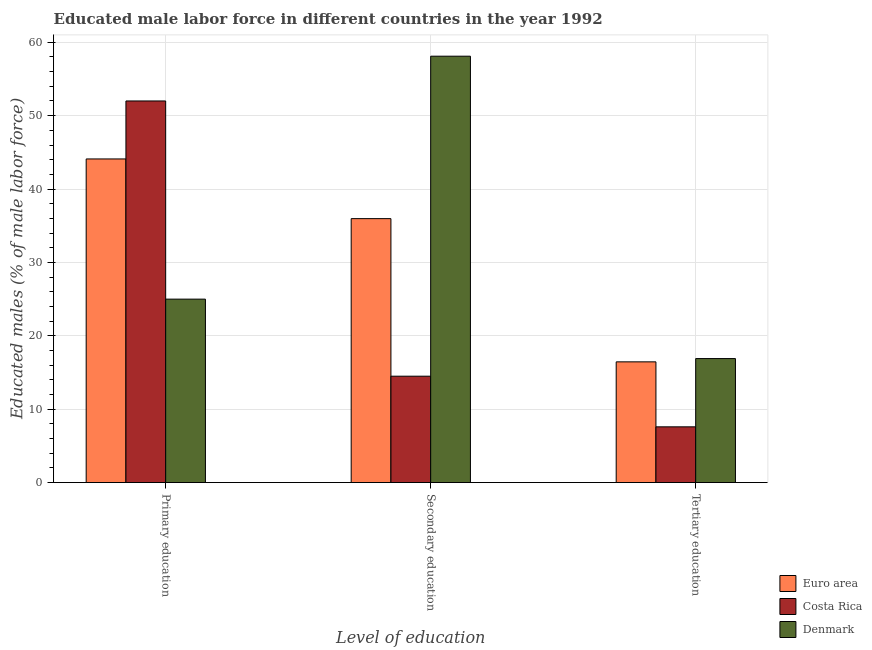Are the number of bars on each tick of the X-axis equal?
Keep it short and to the point. Yes. How many bars are there on the 1st tick from the right?
Give a very brief answer. 3. What is the percentage of male labor force who received secondary education in Euro area?
Offer a terse response. 35.97. Across all countries, what is the maximum percentage of male labor force who received tertiary education?
Give a very brief answer. 16.9. Across all countries, what is the minimum percentage of male labor force who received secondary education?
Offer a terse response. 14.5. In which country was the percentage of male labor force who received primary education maximum?
Provide a succinct answer. Costa Rica. What is the total percentage of male labor force who received tertiary education in the graph?
Ensure brevity in your answer.  40.95. What is the difference between the percentage of male labor force who received secondary education in Euro area and that in Denmark?
Make the answer very short. -22.13. What is the difference between the percentage of male labor force who received primary education in Euro area and the percentage of male labor force who received tertiary education in Costa Rica?
Offer a terse response. 36.5. What is the average percentage of male labor force who received primary education per country?
Keep it short and to the point. 40.37. What is the difference between the percentage of male labor force who received primary education and percentage of male labor force who received secondary education in Denmark?
Make the answer very short. -33.1. What is the ratio of the percentage of male labor force who received tertiary education in Denmark to that in Euro area?
Offer a very short reply. 1.03. Is the percentage of male labor force who received secondary education in Denmark less than that in Costa Rica?
Your answer should be very brief. No. What is the difference between the highest and the second highest percentage of male labor force who received secondary education?
Make the answer very short. 22.13. What is the difference between the highest and the lowest percentage of male labor force who received tertiary education?
Provide a succinct answer. 9.3. Is the sum of the percentage of male labor force who received primary education in Costa Rica and Euro area greater than the maximum percentage of male labor force who received secondary education across all countries?
Your answer should be compact. Yes. What does the 1st bar from the left in Tertiary education represents?
Provide a succinct answer. Euro area. What does the 3rd bar from the right in Secondary education represents?
Your answer should be very brief. Euro area. How many bars are there?
Provide a succinct answer. 9. How many countries are there in the graph?
Offer a very short reply. 3. Are the values on the major ticks of Y-axis written in scientific E-notation?
Keep it short and to the point. No. Does the graph contain any zero values?
Your answer should be compact. No. Does the graph contain grids?
Give a very brief answer. Yes. What is the title of the graph?
Provide a short and direct response. Educated male labor force in different countries in the year 1992. Does "High income: OECD" appear as one of the legend labels in the graph?
Your answer should be very brief. No. What is the label or title of the X-axis?
Your answer should be very brief. Level of education. What is the label or title of the Y-axis?
Your response must be concise. Educated males (% of male labor force). What is the Educated males (% of male labor force) of Euro area in Primary education?
Your response must be concise. 44.1. What is the Educated males (% of male labor force) of Euro area in Secondary education?
Ensure brevity in your answer.  35.97. What is the Educated males (% of male labor force) of Costa Rica in Secondary education?
Offer a very short reply. 14.5. What is the Educated males (% of male labor force) of Denmark in Secondary education?
Provide a succinct answer. 58.1. What is the Educated males (% of male labor force) of Euro area in Tertiary education?
Your answer should be very brief. 16.45. What is the Educated males (% of male labor force) in Costa Rica in Tertiary education?
Offer a very short reply. 7.6. What is the Educated males (% of male labor force) in Denmark in Tertiary education?
Your answer should be very brief. 16.9. Across all Level of education, what is the maximum Educated males (% of male labor force) in Euro area?
Make the answer very short. 44.1. Across all Level of education, what is the maximum Educated males (% of male labor force) of Denmark?
Your response must be concise. 58.1. Across all Level of education, what is the minimum Educated males (% of male labor force) in Euro area?
Give a very brief answer. 16.45. Across all Level of education, what is the minimum Educated males (% of male labor force) of Costa Rica?
Ensure brevity in your answer.  7.6. Across all Level of education, what is the minimum Educated males (% of male labor force) in Denmark?
Give a very brief answer. 16.9. What is the total Educated males (% of male labor force) in Euro area in the graph?
Ensure brevity in your answer.  96.52. What is the total Educated males (% of male labor force) in Costa Rica in the graph?
Ensure brevity in your answer.  74.1. What is the total Educated males (% of male labor force) in Denmark in the graph?
Provide a succinct answer. 100. What is the difference between the Educated males (% of male labor force) in Euro area in Primary education and that in Secondary education?
Provide a short and direct response. 8.13. What is the difference between the Educated males (% of male labor force) of Costa Rica in Primary education and that in Secondary education?
Your answer should be very brief. 37.5. What is the difference between the Educated males (% of male labor force) in Denmark in Primary education and that in Secondary education?
Ensure brevity in your answer.  -33.1. What is the difference between the Educated males (% of male labor force) of Euro area in Primary education and that in Tertiary education?
Your response must be concise. 27.65. What is the difference between the Educated males (% of male labor force) of Costa Rica in Primary education and that in Tertiary education?
Give a very brief answer. 44.4. What is the difference between the Educated males (% of male labor force) in Euro area in Secondary education and that in Tertiary education?
Provide a short and direct response. 19.52. What is the difference between the Educated males (% of male labor force) of Costa Rica in Secondary education and that in Tertiary education?
Provide a succinct answer. 6.9. What is the difference between the Educated males (% of male labor force) of Denmark in Secondary education and that in Tertiary education?
Provide a short and direct response. 41.2. What is the difference between the Educated males (% of male labor force) in Euro area in Primary education and the Educated males (% of male labor force) in Costa Rica in Secondary education?
Your answer should be very brief. 29.6. What is the difference between the Educated males (% of male labor force) of Euro area in Primary education and the Educated males (% of male labor force) of Denmark in Secondary education?
Give a very brief answer. -14. What is the difference between the Educated males (% of male labor force) of Costa Rica in Primary education and the Educated males (% of male labor force) of Denmark in Secondary education?
Make the answer very short. -6.1. What is the difference between the Educated males (% of male labor force) of Euro area in Primary education and the Educated males (% of male labor force) of Costa Rica in Tertiary education?
Offer a terse response. 36.5. What is the difference between the Educated males (% of male labor force) of Euro area in Primary education and the Educated males (% of male labor force) of Denmark in Tertiary education?
Give a very brief answer. 27.2. What is the difference between the Educated males (% of male labor force) in Costa Rica in Primary education and the Educated males (% of male labor force) in Denmark in Tertiary education?
Make the answer very short. 35.1. What is the difference between the Educated males (% of male labor force) of Euro area in Secondary education and the Educated males (% of male labor force) of Costa Rica in Tertiary education?
Ensure brevity in your answer.  28.37. What is the difference between the Educated males (% of male labor force) in Euro area in Secondary education and the Educated males (% of male labor force) in Denmark in Tertiary education?
Make the answer very short. 19.07. What is the average Educated males (% of male labor force) of Euro area per Level of education?
Keep it short and to the point. 32.17. What is the average Educated males (% of male labor force) in Costa Rica per Level of education?
Provide a short and direct response. 24.7. What is the average Educated males (% of male labor force) in Denmark per Level of education?
Offer a terse response. 33.33. What is the difference between the Educated males (% of male labor force) in Euro area and Educated males (% of male labor force) in Costa Rica in Primary education?
Your response must be concise. -7.9. What is the difference between the Educated males (% of male labor force) of Euro area and Educated males (% of male labor force) of Denmark in Primary education?
Your answer should be very brief. 19.1. What is the difference between the Educated males (% of male labor force) in Costa Rica and Educated males (% of male labor force) in Denmark in Primary education?
Ensure brevity in your answer.  27. What is the difference between the Educated males (% of male labor force) of Euro area and Educated males (% of male labor force) of Costa Rica in Secondary education?
Offer a very short reply. 21.47. What is the difference between the Educated males (% of male labor force) in Euro area and Educated males (% of male labor force) in Denmark in Secondary education?
Ensure brevity in your answer.  -22.13. What is the difference between the Educated males (% of male labor force) of Costa Rica and Educated males (% of male labor force) of Denmark in Secondary education?
Offer a very short reply. -43.6. What is the difference between the Educated males (% of male labor force) in Euro area and Educated males (% of male labor force) in Costa Rica in Tertiary education?
Provide a succinct answer. 8.85. What is the difference between the Educated males (% of male labor force) in Euro area and Educated males (% of male labor force) in Denmark in Tertiary education?
Keep it short and to the point. -0.45. What is the difference between the Educated males (% of male labor force) of Costa Rica and Educated males (% of male labor force) of Denmark in Tertiary education?
Your answer should be compact. -9.3. What is the ratio of the Educated males (% of male labor force) in Euro area in Primary education to that in Secondary education?
Provide a short and direct response. 1.23. What is the ratio of the Educated males (% of male labor force) in Costa Rica in Primary education to that in Secondary education?
Your answer should be very brief. 3.59. What is the ratio of the Educated males (% of male labor force) of Denmark in Primary education to that in Secondary education?
Your response must be concise. 0.43. What is the ratio of the Educated males (% of male labor force) of Euro area in Primary education to that in Tertiary education?
Provide a succinct answer. 2.68. What is the ratio of the Educated males (% of male labor force) in Costa Rica in Primary education to that in Tertiary education?
Offer a very short reply. 6.84. What is the ratio of the Educated males (% of male labor force) of Denmark in Primary education to that in Tertiary education?
Offer a terse response. 1.48. What is the ratio of the Educated males (% of male labor force) in Euro area in Secondary education to that in Tertiary education?
Offer a terse response. 2.19. What is the ratio of the Educated males (% of male labor force) in Costa Rica in Secondary education to that in Tertiary education?
Keep it short and to the point. 1.91. What is the ratio of the Educated males (% of male labor force) of Denmark in Secondary education to that in Tertiary education?
Offer a very short reply. 3.44. What is the difference between the highest and the second highest Educated males (% of male labor force) of Euro area?
Give a very brief answer. 8.13. What is the difference between the highest and the second highest Educated males (% of male labor force) in Costa Rica?
Give a very brief answer. 37.5. What is the difference between the highest and the second highest Educated males (% of male labor force) of Denmark?
Your answer should be compact. 33.1. What is the difference between the highest and the lowest Educated males (% of male labor force) in Euro area?
Offer a terse response. 27.65. What is the difference between the highest and the lowest Educated males (% of male labor force) of Costa Rica?
Keep it short and to the point. 44.4. What is the difference between the highest and the lowest Educated males (% of male labor force) of Denmark?
Keep it short and to the point. 41.2. 